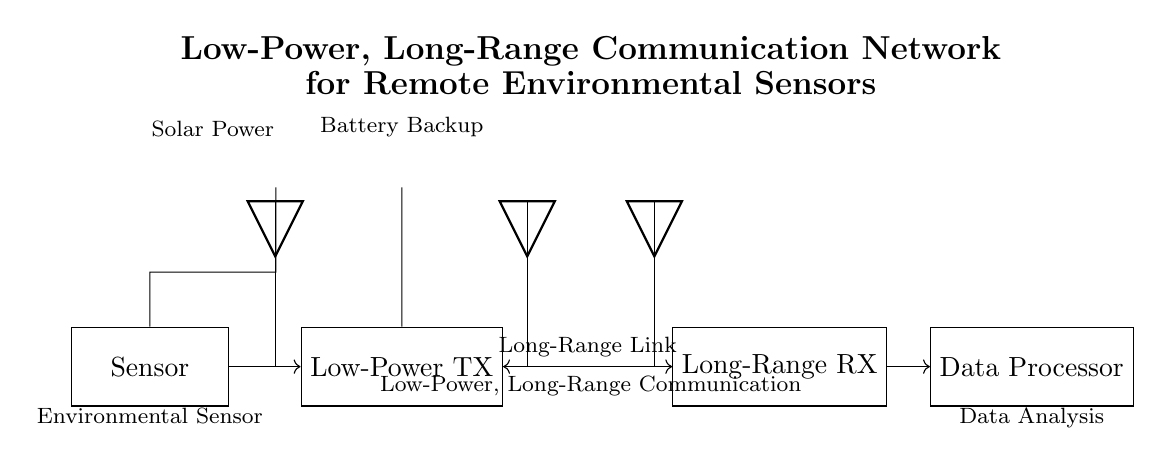What type of power source does the sensor use? The sensor is powered by a solar panel, which is represented in the diagram as a source connected directly to the sensor.
Answer: Solar power What is the primary function of the low-power transmitter? The primary function of the low-power transmitter is to send data from the environmental sensor to the long-range receiver, indicated by the directional arrow connecting the two components.
Answer: Data transmission How does the long-range receiver receive signals? The long-range receiver receives signals through a long-range link established with the transmitter, as shown by the bidirectional arrow connecting them.
Answer: Long-range link What component stores backup energy in this circuit? The backup energy is stored in the battery, which is depicted in the diagram and connected to the low-power transmitter.
Answer: Battery What is the purpose of the data processor in this circuit? The data processor analyzes the data received from the long-range receiver, as indicated by the directional arrow leading from the receiver to the processor.
Answer: Data analysis How does the environmental sensor communicate with the low-power transmitter? The environmental sensor communicates with the low-power transmitter through a direct connection, represented by a simple directional arrow between them.
Answer: Direct connection 